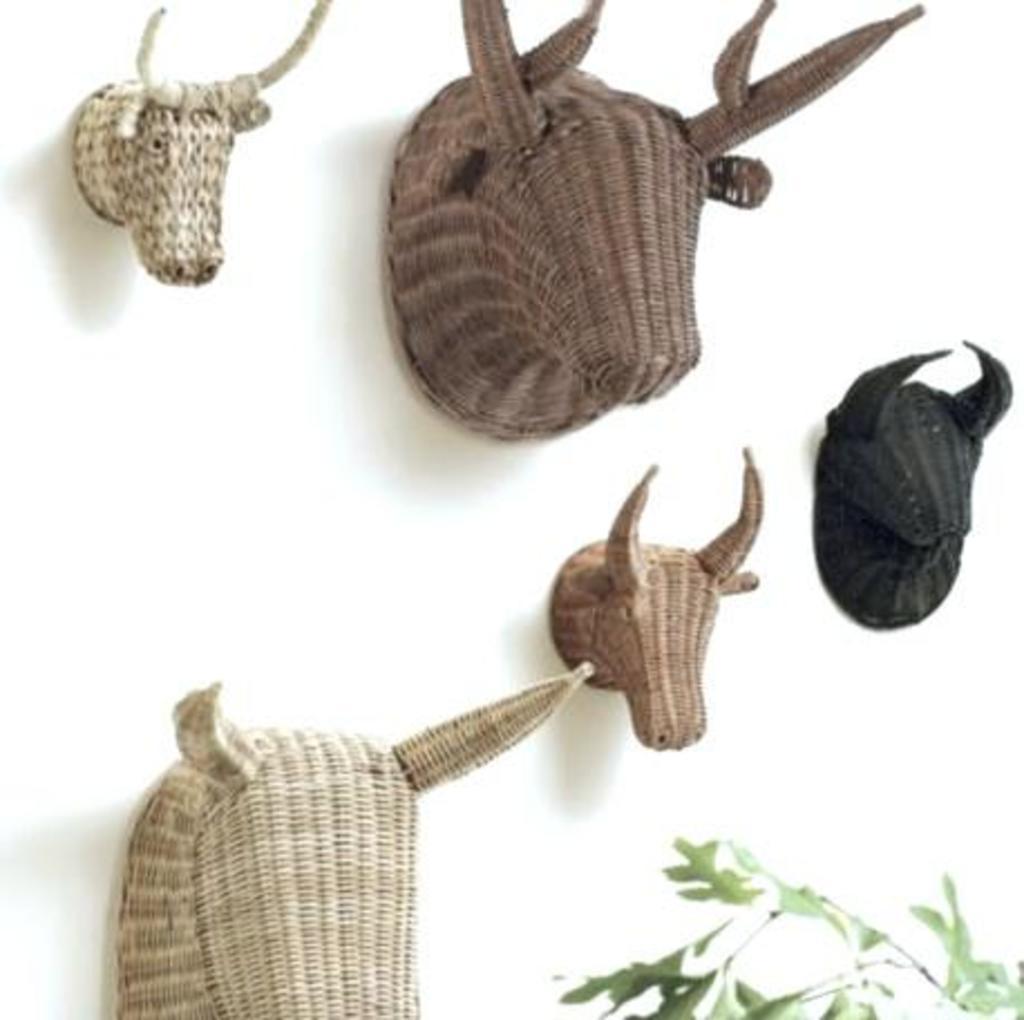Could you give a brief overview of what you see in this image? In this image I can see an animal faces which are made of wood. I can see these faces are in cream, black and brown color. To the side I can see the plant. These faces are attached to the white color surface. 